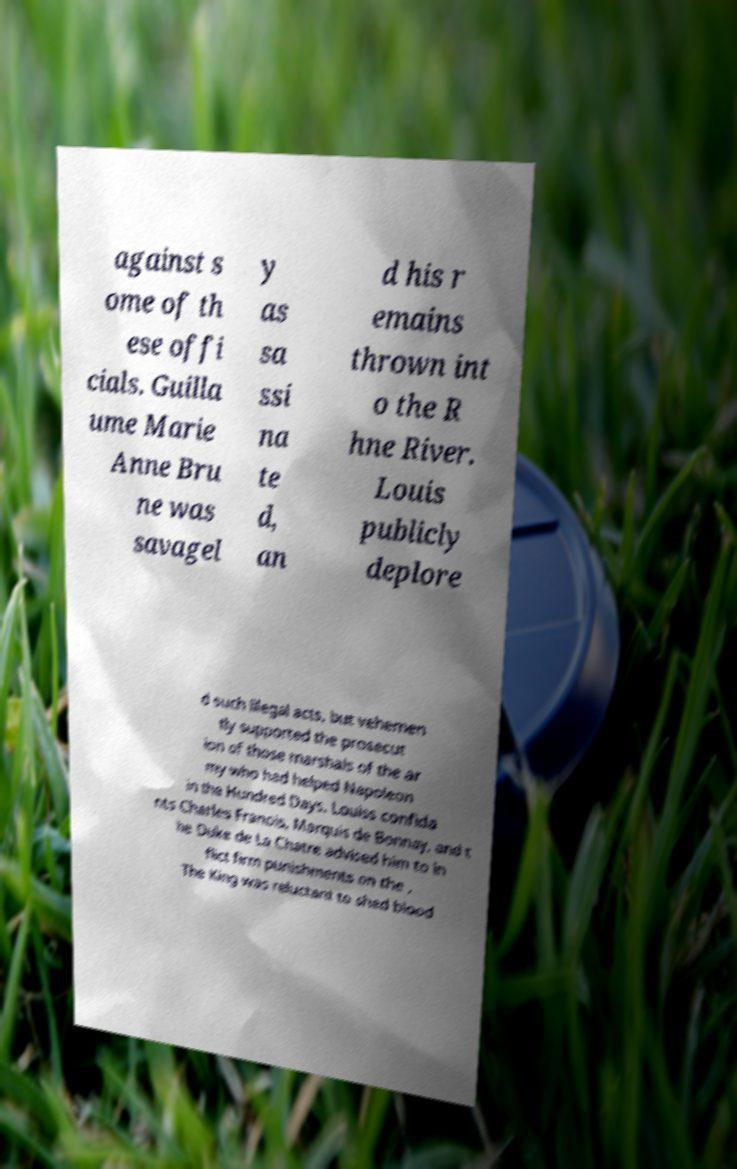Can you read and provide the text displayed in the image?This photo seems to have some interesting text. Can you extract and type it out for me? against s ome of th ese offi cials. Guilla ume Marie Anne Bru ne was savagel y as sa ssi na te d, an d his r emains thrown int o the R hne River. Louis publicly deplore d such illegal acts, but vehemen tly supported the prosecut ion of those marshals of the ar my who had helped Napoleon in the Hundred Days. Louiss confida nts Charles Franois, Marquis de Bonnay, and t he Duke de La Chatre advised him to in flict firm punishments on the . The King was reluctant to shed blood 